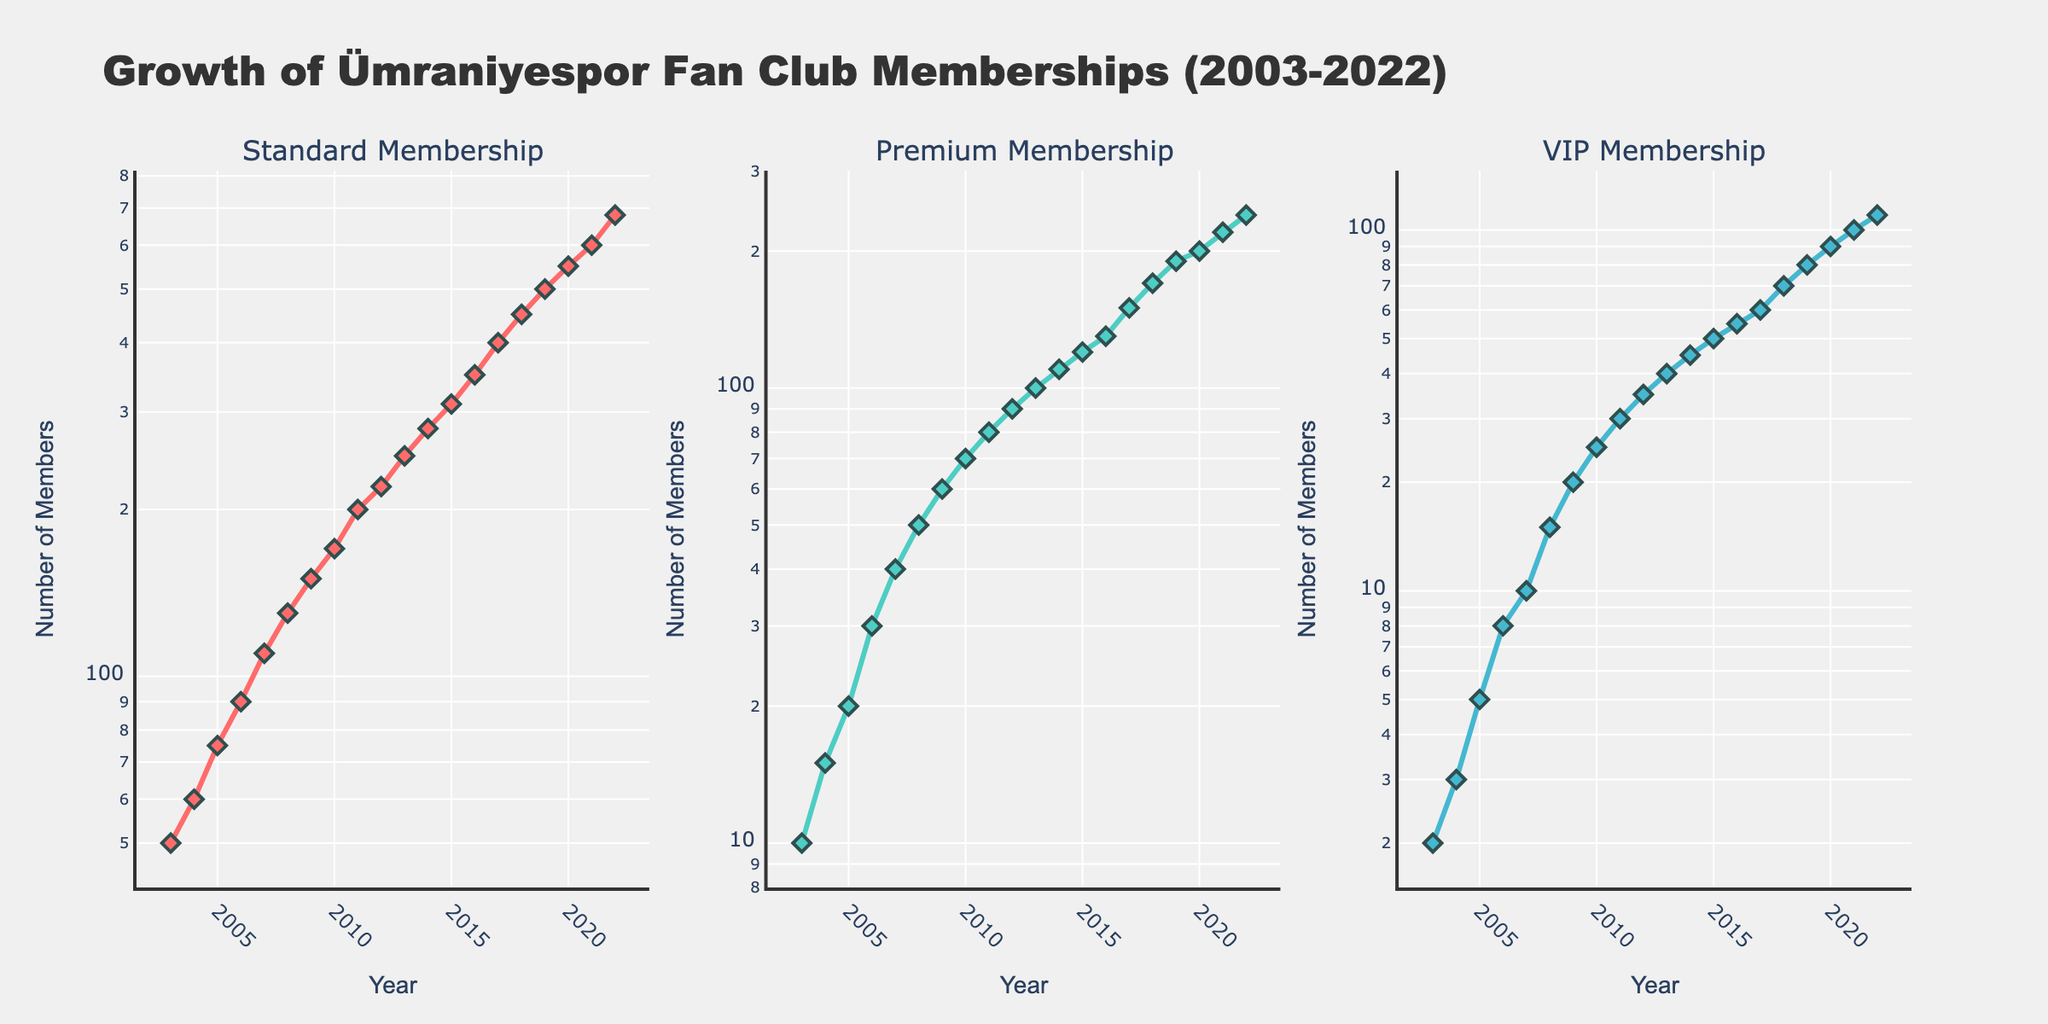What is the title of the plot? The title of the plot is located at the top and centered. It summarizes the main topic of the figure, which is about the growth of Ümraniyespor fan club memberships over a period of time.
Answer: Growth of Ümraniyespor Fan Club Memberships (2003-2022) How many subplots are there in the figure? The figure has multiple sections representing different membership types, specified in its layout. Looking at the plot, there are three distinct subplots.
Answer: 3 What is the y-axis scale type used in the figure? The y-axes in each subplot employ a specific scale type, indicated by the labeling and evenly spaced increments that increase multiplicatively. This type is useful for a wide range of data.
Answer: Log scale In which year did the Standard Membership first exceed 300 members? Examine the first subplot for Standard Membership and locate the year at which the y-value crosses the 300 mark.
Answer: 2015 Which membership type has the least number of members in 2003? Compare the data points for each subplot for the year 2003, checking the y-values to determine the smallest number.
Answer: VIP Membership How many VIP members were there in 2019? Reference the third subplot for VIP Membership and locate the y-value corresponding to the year 2019.
Answer: 80 What is the difference in the number of Standard and Premium memberships in 2010? Find the y-values for both Standard and Premium memberships in the subplots for the year 2010, then subtract the smaller value from the larger one.
Answer: 100 In which year did the Premium Membership surpass 200 members? Check the second subplot for Premium Membership and identify the year when the y-value exceeds 200.
Answer: 2020 When did VIP Membership hit 100 members? Look at the third subplot and find the year when the y-value reaches 100. This corresponds to a crucial milestone in the VIP Membership growth.
Answer: 2021 What is the overall trend observed in Standard, Premium, and VIP Memberships over the given period? By examining the slope of the lines in all subplots, notice that the memberships for all categories follow a trajectory that represents consistent growth over time.
Answer: Increasing 